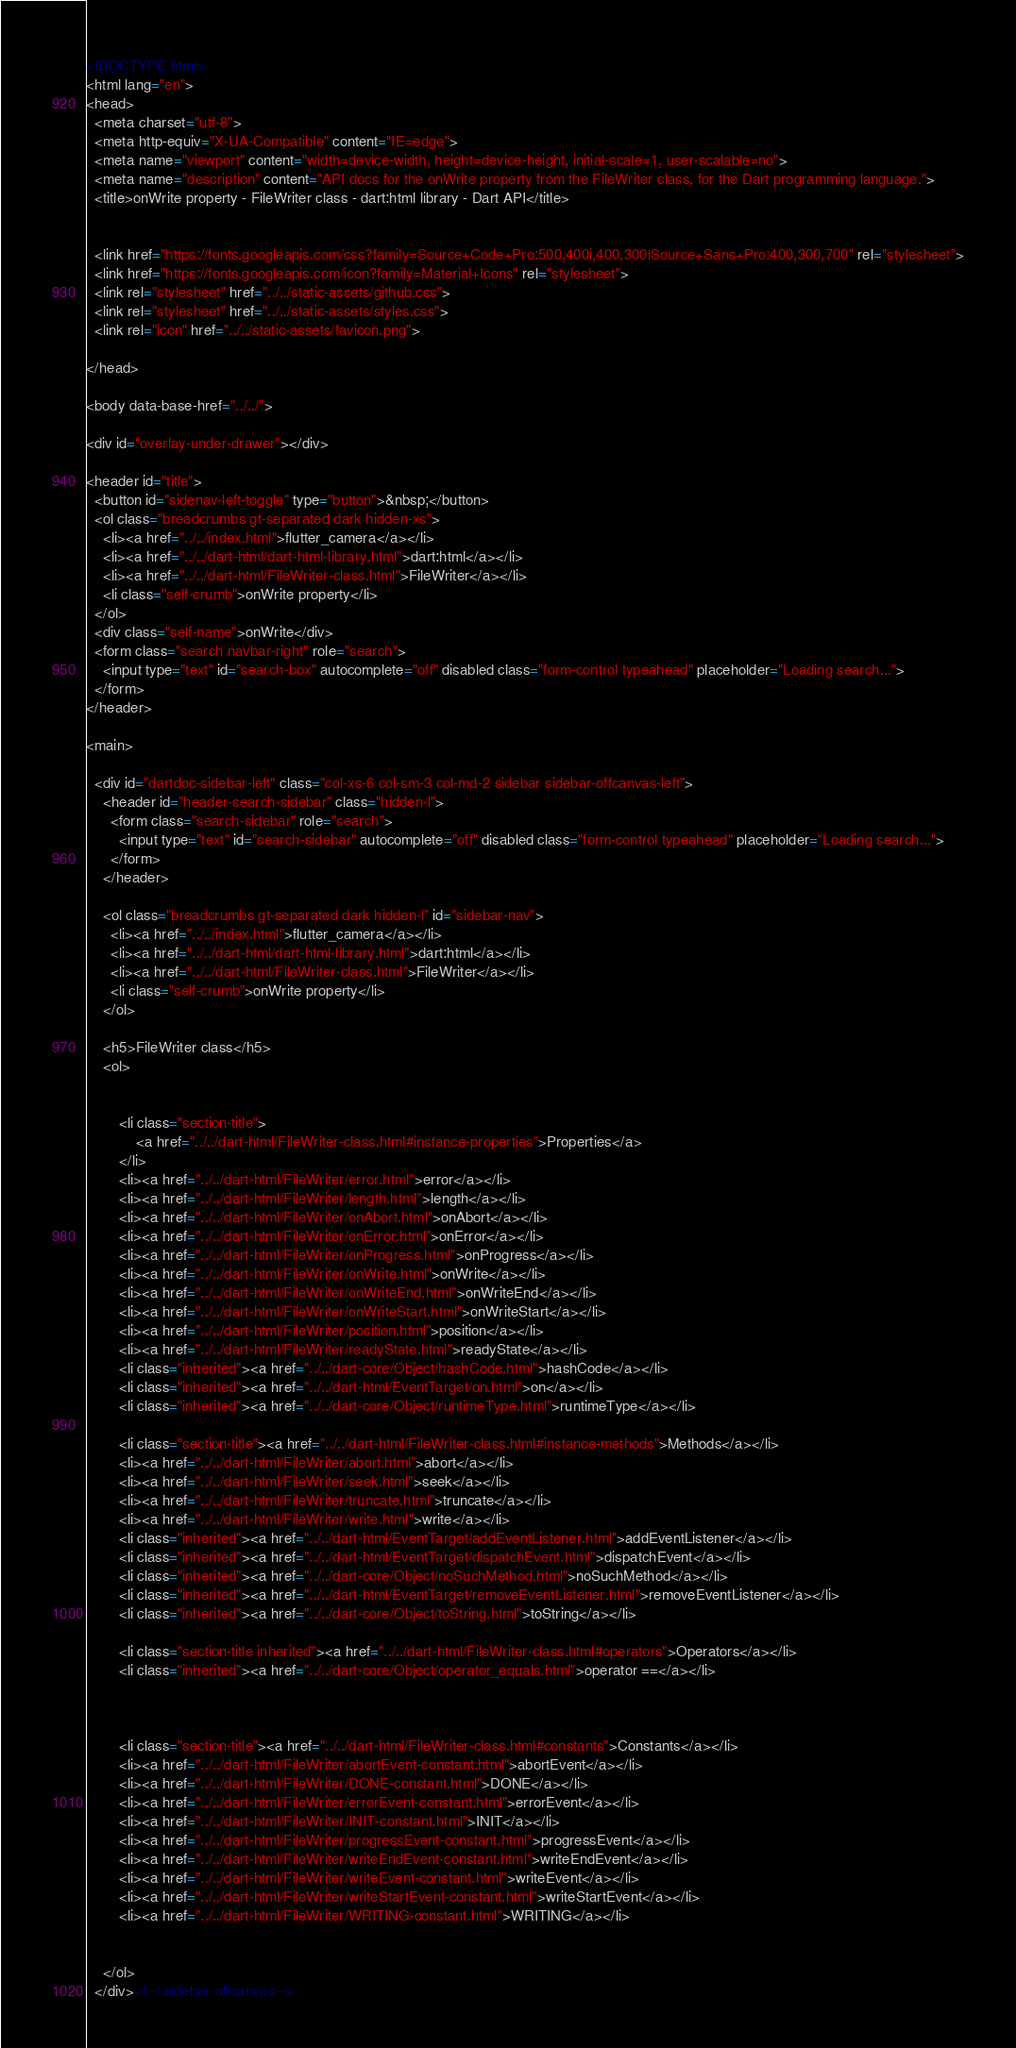<code> <loc_0><loc_0><loc_500><loc_500><_HTML_><!DOCTYPE html>
<html lang="en">
<head>
  <meta charset="utf-8">
  <meta http-equiv="X-UA-Compatible" content="IE=edge">
  <meta name="viewport" content="width=device-width, height=device-height, initial-scale=1, user-scalable=no">
  <meta name="description" content="API docs for the onWrite property from the FileWriter class, for the Dart programming language.">
  <title>onWrite property - FileWriter class - dart:html library - Dart API</title>

  
  <link href="https://fonts.googleapis.com/css?family=Source+Code+Pro:500,400i,400,300|Source+Sans+Pro:400,300,700" rel="stylesheet">
  <link href="https://fonts.googleapis.com/icon?family=Material+Icons" rel="stylesheet">
  <link rel="stylesheet" href="../../static-assets/github.css">
  <link rel="stylesheet" href="../../static-assets/styles.css">
  <link rel="icon" href="../../static-assets/favicon.png">

</head>

<body data-base-href="../../">

<div id="overlay-under-drawer"></div>

<header id="title">
  <button id="sidenav-left-toggle" type="button">&nbsp;</button>
  <ol class="breadcrumbs gt-separated dark hidden-xs">
    <li><a href="../../index.html">flutter_camera</a></li>
    <li><a href="../../dart-html/dart-html-library.html">dart:html</a></li>
    <li><a href="../../dart-html/FileWriter-class.html">FileWriter</a></li>
    <li class="self-crumb">onWrite property</li>
  </ol>
  <div class="self-name">onWrite</div>
  <form class="search navbar-right" role="search">
    <input type="text" id="search-box" autocomplete="off" disabled class="form-control typeahead" placeholder="Loading search...">
  </form>
</header>

<main>

  <div id="dartdoc-sidebar-left" class="col-xs-6 col-sm-3 col-md-2 sidebar sidebar-offcanvas-left">
    <header id="header-search-sidebar" class="hidden-l">
      <form class="search-sidebar" role="search">
        <input type="text" id="search-sidebar" autocomplete="off" disabled class="form-control typeahead" placeholder="Loading search...">
      </form>
    </header>
    
    <ol class="breadcrumbs gt-separated dark hidden-l" id="sidebar-nav">
      <li><a href="../../index.html">flutter_camera</a></li>
      <li><a href="../../dart-html/dart-html-library.html">dart:html</a></li>
      <li><a href="../../dart-html/FileWriter-class.html">FileWriter</a></li>
      <li class="self-crumb">onWrite property</li>
    </ol>
    
    <h5>FileWriter class</h5>
    <ol>
    
    
        <li class="section-title">
            <a href="../../dart-html/FileWriter-class.html#instance-properties">Properties</a>
        </li>
        <li><a href="../../dart-html/FileWriter/error.html">error</a></li>
        <li><a href="../../dart-html/FileWriter/length.html">length</a></li>
        <li><a href="../../dart-html/FileWriter/onAbort.html">onAbort</a></li>
        <li><a href="../../dart-html/FileWriter/onError.html">onError</a></li>
        <li><a href="../../dart-html/FileWriter/onProgress.html">onProgress</a></li>
        <li><a href="../../dart-html/FileWriter/onWrite.html">onWrite</a></li>
        <li><a href="../../dart-html/FileWriter/onWriteEnd.html">onWriteEnd</a></li>
        <li><a href="../../dart-html/FileWriter/onWriteStart.html">onWriteStart</a></li>
        <li><a href="../../dart-html/FileWriter/position.html">position</a></li>
        <li><a href="../../dart-html/FileWriter/readyState.html">readyState</a></li>
        <li class="inherited"><a href="../../dart-core/Object/hashCode.html">hashCode</a></li>
        <li class="inherited"><a href="../../dart-html/EventTarget/on.html">on</a></li>
        <li class="inherited"><a href="../../dart-core/Object/runtimeType.html">runtimeType</a></li>
    
        <li class="section-title"><a href="../../dart-html/FileWriter-class.html#instance-methods">Methods</a></li>
        <li><a href="../../dart-html/FileWriter/abort.html">abort</a></li>
        <li><a href="../../dart-html/FileWriter/seek.html">seek</a></li>
        <li><a href="../../dart-html/FileWriter/truncate.html">truncate</a></li>
        <li><a href="../../dart-html/FileWriter/write.html">write</a></li>
        <li class="inherited"><a href="../../dart-html/EventTarget/addEventListener.html">addEventListener</a></li>
        <li class="inherited"><a href="../../dart-html/EventTarget/dispatchEvent.html">dispatchEvent</a></li>
        <li class="inherited"><a href="../../dart-core/Object/noSuchMethod.html">noSuchMethod</a></li>
        <li class="inherited"><a href="../../dart-html/EventTarget/removeEventListener.html">removeEventListener</a></li>
        <li class="inherited"><a href="../../dart-core/Object/toString.html">toString</a></li>
    
        <li class="section-title inherited"><a href="../../dart-html/FileWriter-class.html#operators">Operators</a></li>
        <li class="inherited"><a href="../../dart-core/Object/operator_equals.html">operator ==</a></li>
    
    
    
        <li class="section-title"><a href="../../dart-html/FileWriter-class.html#constants">Constants</a></li>
        <li><a href="../../dart-html/FileWriter/abortEvent-constant.html">abortEvent</a></li>
        <li><a href="../../dart-html/FileWriter/DONE-constant.html">DONE</a></li>
        <li><a href="../../dart-html/FileWriter/errorEvent-constant.html">errorEvent</a></li>
        <li><a href="../../dart-html/FileWriter/INIT-constant.html">INIT</a></li>
        <li><a href="../../dart-html/FileWriter/progressEvent-constant.html">progressEvent</a></li>
        <li><a href="../../dart-html/FileWriter/writeEndEvent-constant.html">writeEndEvent</a></li>
        <li><a href="../../dart-html/FileWriter/writeEvent-constant.html">writeEvent</a></li>
        <li><a href="../../dart-html/FileWriter/writeStartEvent-constant.html">writeStartEvent</a></li>
        <li><a href="../../dart-html/FileWriter/WRITING-constant.html">WRITING</a></li>
    
    
    </ol>
  </div><!--/.sidebar-offcanvas-->
</code> 